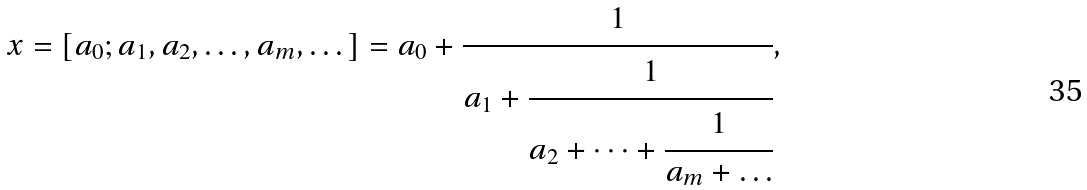Convert formula to latex. <formula><loc_0><loc_0><loc_500><loc_500>x = [ a _ { 0 } ; a _ { 1 } , a _ { 2 } , \dots , a _ { m } , \dots ] = a _ { 0 } + \cfrac { 1 } { a _ { 1 } + \cfrac { 1 } { a _ { 2 } + \dots + \cfrac { 1 } { a _ { m } + \dots } } } ,</formula> 